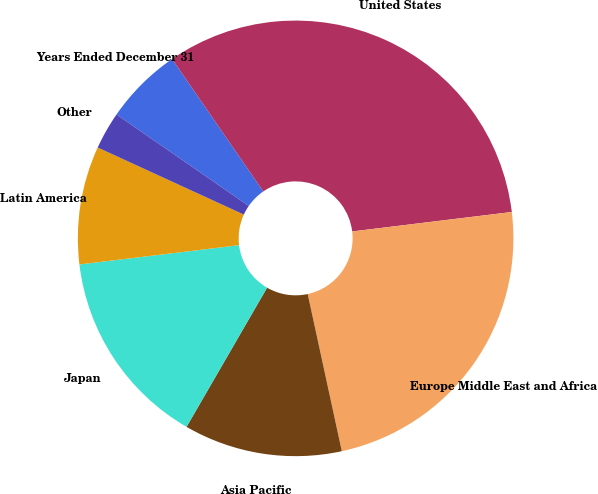Convert chart to OTSL. <chart><loc_0><loc_0><loc_500><loc_500><pie_chart><fcel>Years Ended December 31<fcel>United States<fcel>Europe Middle East and Africa<fcel>Asia Pacific<fcel>Japan<fcel>Latin America<fcel>Other<nl><fcel>5.77%<fcel>32.67%<fcel>23.53%<fcel>11.75%<fcel>14.74%<fcel>8.76%<fcel>2.78%<nl></chart> 